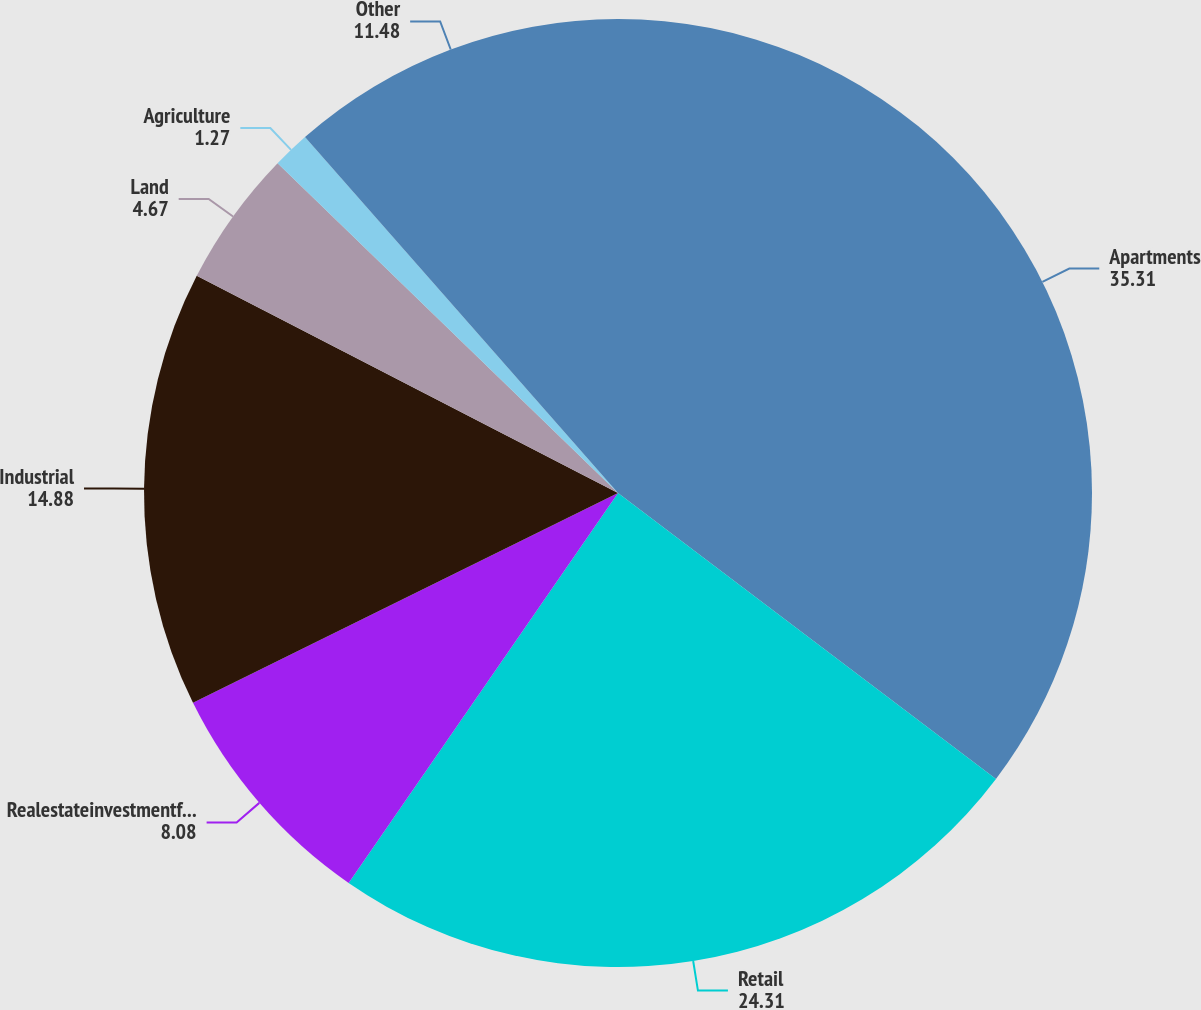<chart> <loc_0><loc_0><loc_500><loc_500><pie_chart><fcel>Apartments<fcel>Retail<fcel>Realestateinvestmentfunds<fcel>Industrial<fcel>Land<fcel>Agriculture<fcel>Other<nl><fcel>35.31%<fcel>24.31%<fcel>8.08%<fcel>14.88%<fcel>4.67%<fcel>1.27%<fcel>11.48%<nl></chart> 